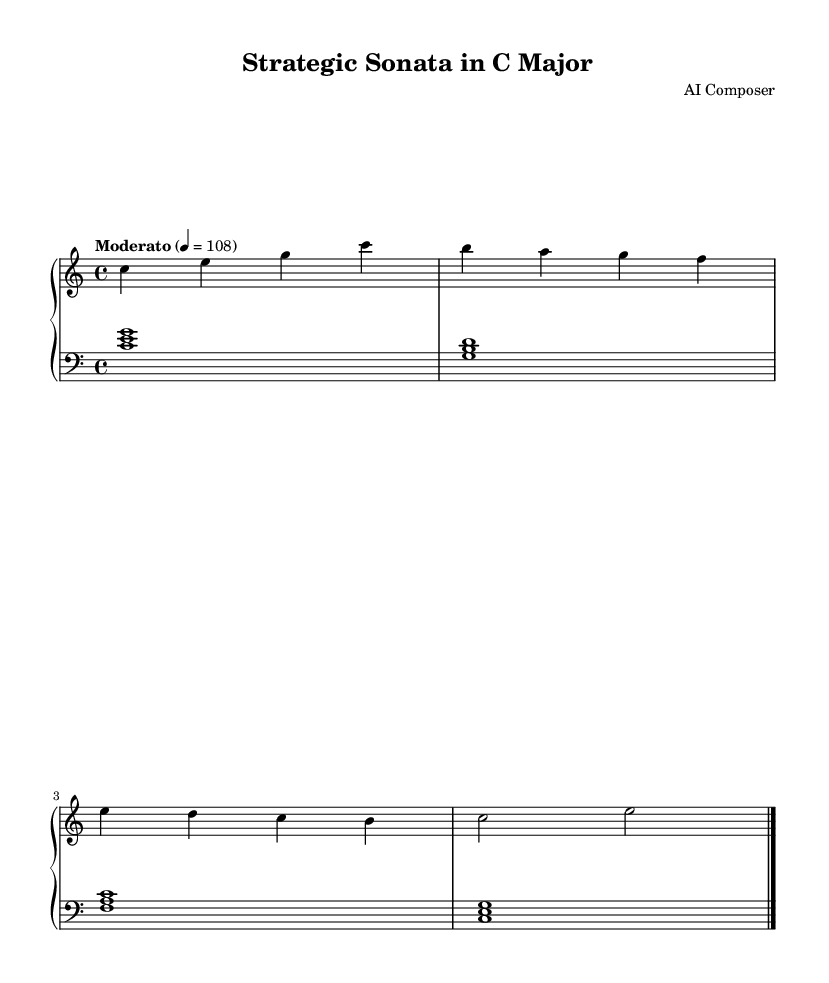What is the key signature of this music? The key signature is indicated at the beginning of the staff and shows no sharps or flats, which represents the key of C major.
Answer: C major What is the time signature of this music? The time signature is placed at the beginning of the score and indicates the number of beats in a measure. Here, it shows 4/4, meaning there are four beats per measure.
Answer: 4/4 What is the tempo marking of the piece? The tempo marking is specified at the beginning, indicating how fast the piece should be played. "Moderato" refers to a moderate speed, and the metronome marking of 108 also confirms this.
Answer: Moderato How many measures are in the provided score? By counting the distinct groups of notes divided by vertical lines (bar lines), we find there are four complete measures demonstrated in the score.
Answer: 4 What musical elements are included in the right hand notation? The right hand notation contains single notes represented as letters (c, e, g, b, a, etc.) in a melodic sequence, identifying pitch and rhythm.
Answer: Melodic sequence What type of harmony is present in the left hand notation? The left hand contains chords represented by brackets, indicating harmonic structure by combining three notes at once, which produces a fuller sound.
Answer: Chords What is the time duration of the last note played in the piece? The last note of the right hand section is a half note, which is represented in the score and indicates its duration.
Answer: Half note 